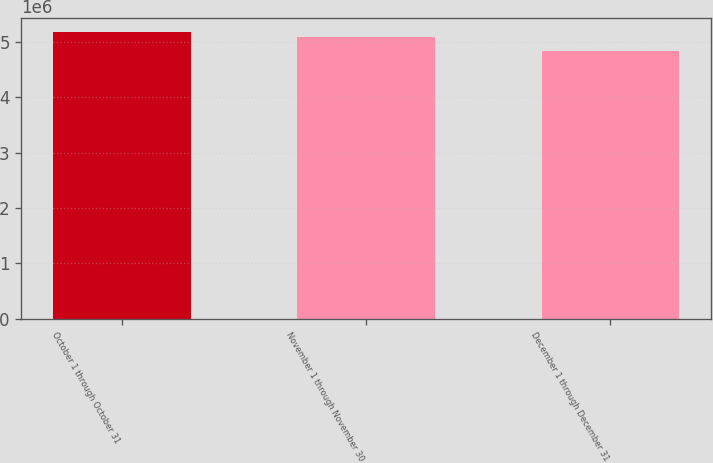<chart> <loc_0><loc_0><loc_500><loc_500><bar_chart><fcel>October 1 through October 31<fcel>November 1 through November 30<fcel>December 1 through December 31<nl><fcel>5.17618e+06<fcel>5.09904e+06<fcel>4.84894e+06<nl></chart> 